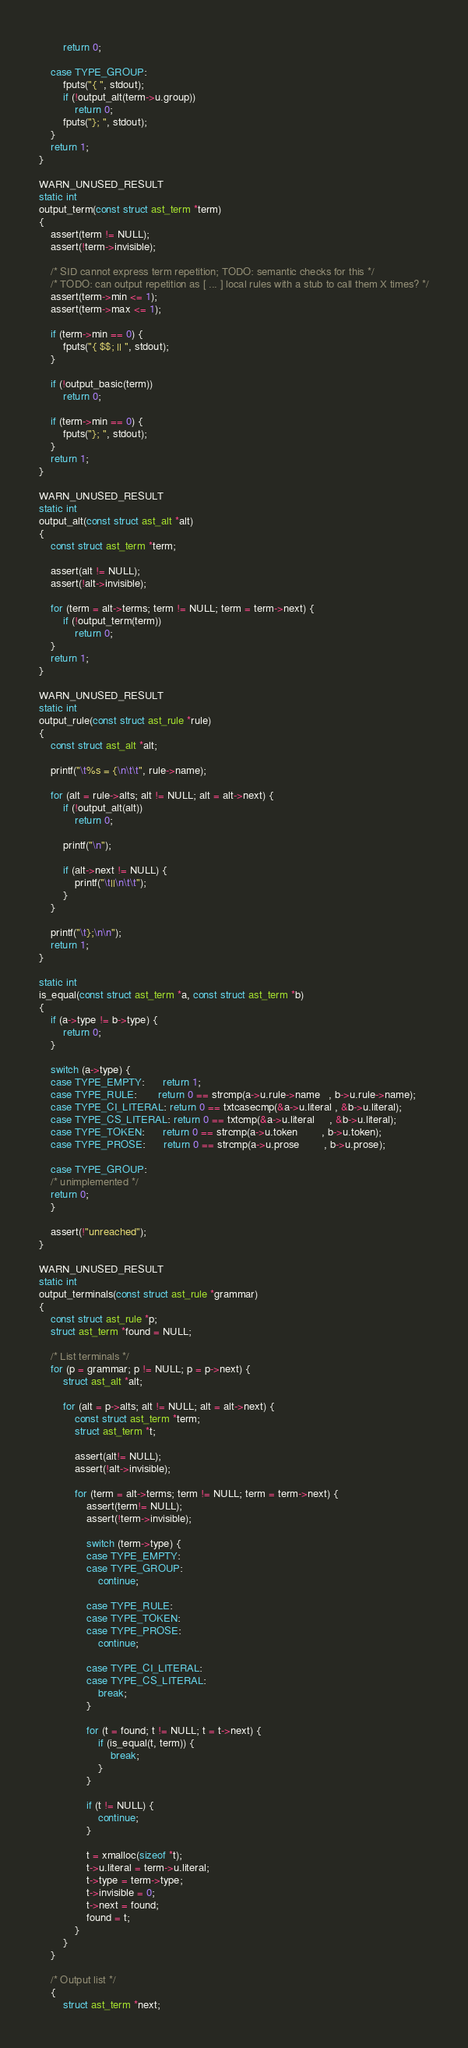<code> <loc_0><loc_0><loc_500><loc_500><_C_>		return 0;

	case TYPE_GROUP:
		fputs("{ ", stdout);
		if (!output_alt(term->u.group))
			return 0;
		fputs("}; ", stdout);
	}
	return 1;
}

WARN_UNUSED_RESULT
static int
output_term(const struct ast_term *term)
{
	assert(term != NULL);
	assert(!term->invisible);

	/* SID cannot express term repetition; TODO: semantic checks for this */
	/* TODO: can output repetition as [ ... ] local rules with a stub to call them X times? */
	assert(term->min <= 1);
	assert(term->max <= 1);

	if (term->min == 0) {
		fputs("{ $$; || ", stdout);
	}

	if (!output_basic(term))
		return 0;

	if (term->min == 0) {
		fputs("}; ", stdout);
	}
	return 1;
}

WARN_UNUSED_RESULT
static int
output_alt(const struct ast_alt *alt)
{
	const struct ast_term *term;

	assert(alt != NULL);
	assert(!alt->invisible);

	for (term = alt->terms; term != NULL; term = term->next) {
		if (!output_term(term))
			return 0;
	}
	return 1;
}

WARN_UNUSED_RESULT
static int
output_rule(const struct ast_rule *rule)
{
	const struct ast_alt *alt;

	printf("\t%s = {\n\t\t", rule->name);

	for (alt = rule->alts; alt != NULL; alt = alt->next) {
		if (!output_alt(alt))
			return 0;

		printf("\n");

		if (alt->next != NULL) {
			printf("\t||\n\t\t");
		}
	}

	printf("\t};\n\n");
	return 1;
}

static int
is_equal(const struct ast_term *a, const struct ast_term *b)
{
	if (a->type != b->type) {
		return 0;
	}

	switch (a->type) {
	case TYPE_EMPTY:      return 1;
	case TYPE_RULE:       return 0 == strcmp(a->u.rule->name   , b->u.rule->name);
	case TYPE_CI_LITERAL: return 0 == txtcasecmp(&a->u.literal , &b->u.literal);
	case TYPE_CS_LITERAL: return 0 == txtcmp(&a->u.literal     , &b->u.literal);
	case TYPE_TOKEN:      return 0 == strcmp(a->u.token        , b->u.token);
	case TYPE_PROSE:      return 0 == strcmp(a->u.prose        , b->u.prose);

	case TYPE_GROUP:
	/* unimplemented */
	return 0;
	}

	assert(!"unreached");
}

WARN_UNUSED_RESULT
static int
output_terminals(const struct ast_rule *grammar)
{
	const struct ast_rule *p;
	struct ast_term *found = NULL;

	/* List terminals */
	for (p = grammar; p != NULL; p = p->next) {
		struct ast_alt *alt;

		for (alt = p->alts; alt != NULL; alt = alt->next) {
			const struct ast_term *term;
			struct ast_term *t;

			assert(alt!= NULL);
			assert(!alt->invisible);

			for (term = alt->terms; term != NULL; term = term->next) {
				assert(term!= NULL);
				assert(!term->invisible);

				switch (term->type) {
				case TYPE_EMPTY:
				case TYPE_GROUP:
					continue;

				case TYPE_RULE:
				case TYPE_TOKEN:
				case TYPE_PROSE:
					continue;

				case TYPE_CI_LITERAL:
				case TYPE_CS_LITERAL:
					break;
				}

				for (t = found; t != NULL; t = t->next) {
					if (is_equal(t, term)) {
						break;
					}
				}

				if (t != NULL) {
					continue;
				}

				t = xmalloc(sizeof *t);
				t->u.literal = term->u.literal;
				t->type = term->type;
				t->invisible = 0;
				t->next = found;
				found = t;
			}
		}
	}

	/* Output list */
	{
		struct ast_term *next;</code> 